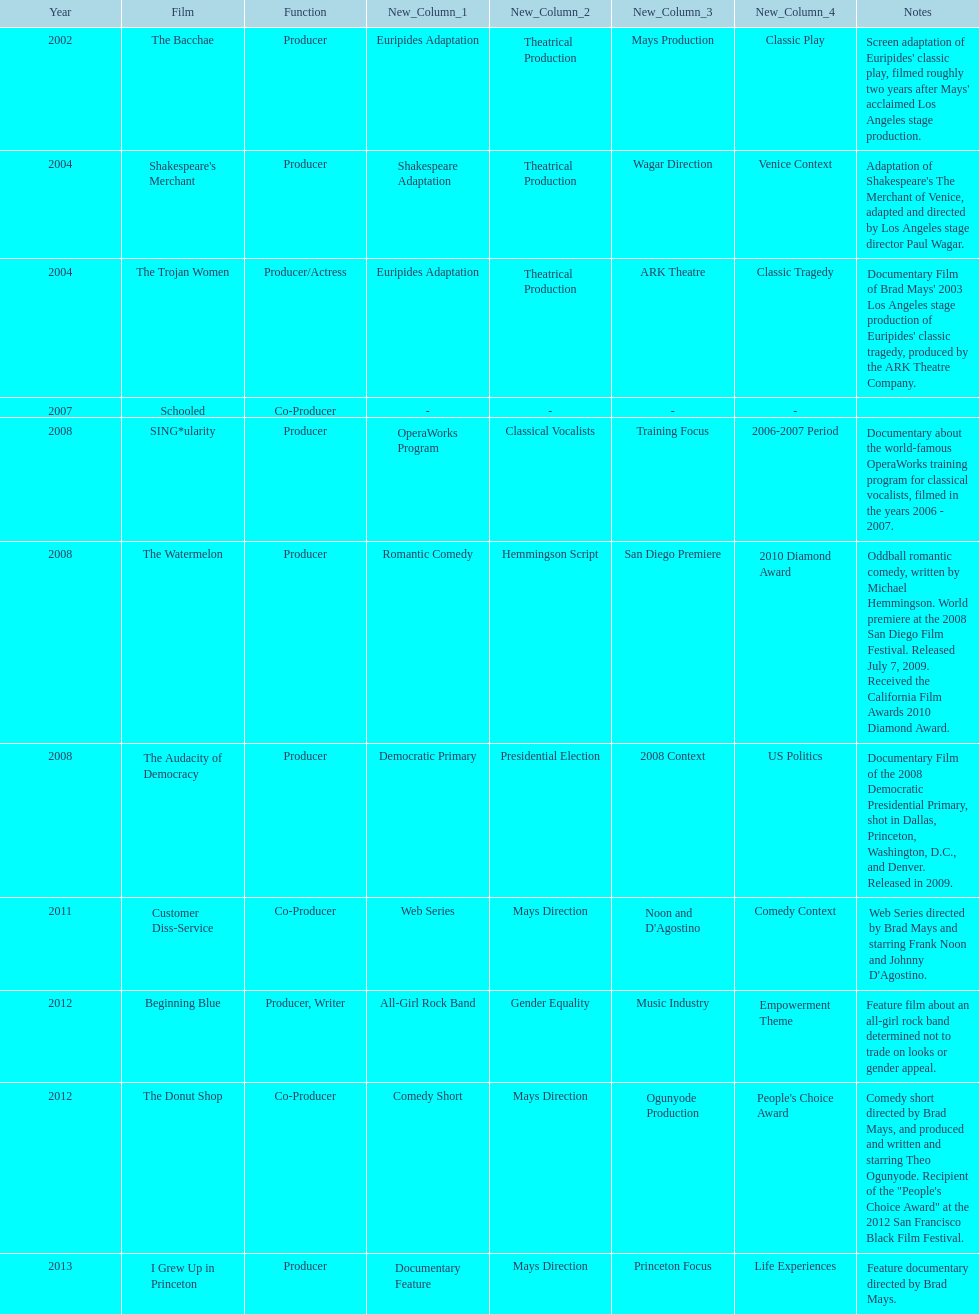Which film was before the audacity of democracy? The Watermelon. 